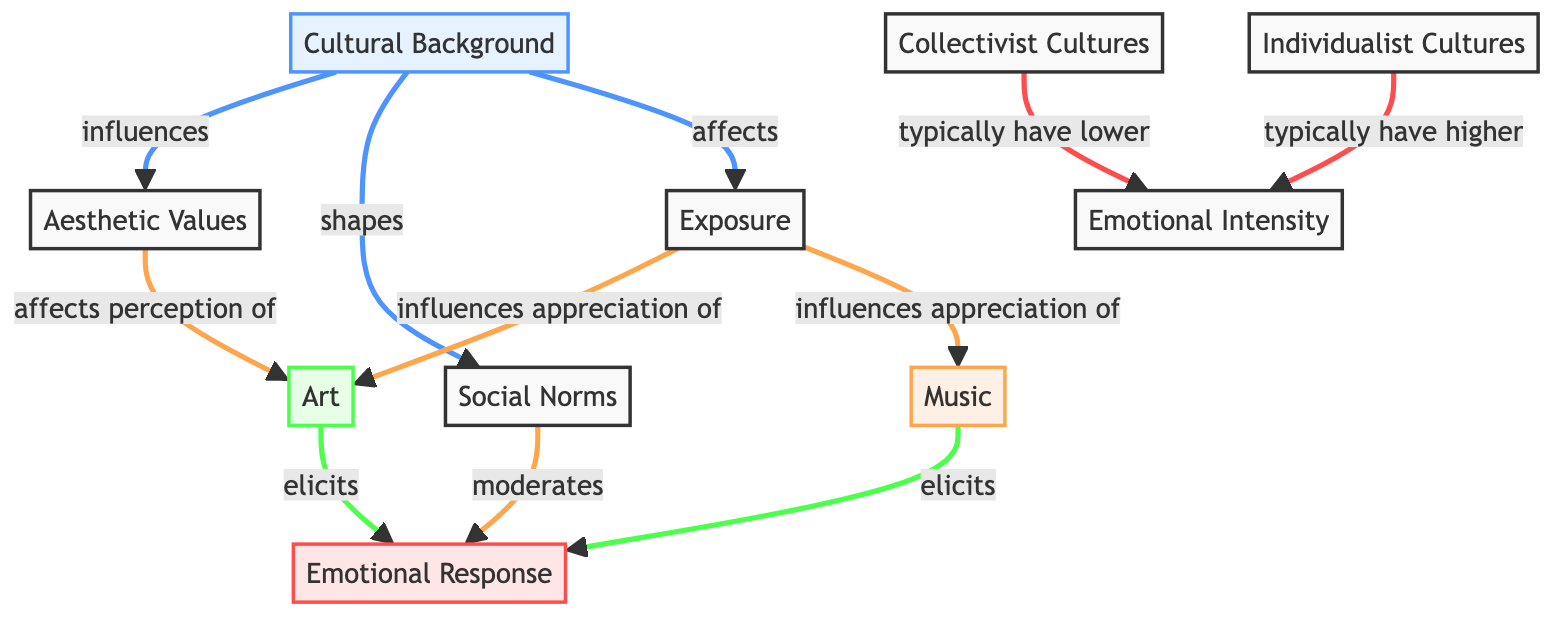What nodes are influenced by Cultural Background? The Cultural Background node influences several other nodes: Aesthetic Values, Social Norms, and Exposure. This is indicated by the directed edges leading from the Cultural Background node to each of these nodes.
Answer: Aesthetic Values, Social Norms, Exposure How does Exposure influence appreciation of Art? The diagram shows that the Exposure node has a direct edge leading to the Art node, indicating that Exposure influences the appreciation of Art.
Answer: Appreciation of Art What type of cultures typically have lower Emotional Intensity? The diagram specifies that Collectivist Cultures typically have lower Emotional Intensity, which is indicated by the edge connecting the Collectivist Cultures node to the Emotional Intensity node.
Answer: Collectivist Cultures What is the total number of nodes in this diagram? By counting each node depicted in the diagram, we find there are 10 distinct nodes.
Answer: 10 What are the effects of Art on Emotional Response? The Art node has a directed edge leading to the Emotional Response node, illustrating that Art elicits an emotional response.
Answer: Elicits Explain the relationship between Cultural Background and Social Norms. The diagram shows a directed edge from the Cultural Background node to the Social Norms node, signifying that Cultural Background shapes Social Norms. This indicates a direct influence.
Answer: Shapes Which cultures typically have higher Emotional Intensity? The Individualist Cultures node is linked to the Emotional Intensity node, indicating that these cultures typically have higher Emotional Intensity.
Answer: Individualist Cultures What do Aesthetic Values affect in the context of the diagram? The Aesthetic Values node has a directed edge indicating it affects the perception of Art and is connected to the Emotional Response indirectly through Art appreciation.
Answer: Perception of Art How many edges connect the Cultural Background node to other nodes? By examining the edges radiating from the Cultural Background node, we can identify that there are three directed edges connecting it to other nodes (Aesthetic Values, Social Norms, and Exposure).
Answer: 3 